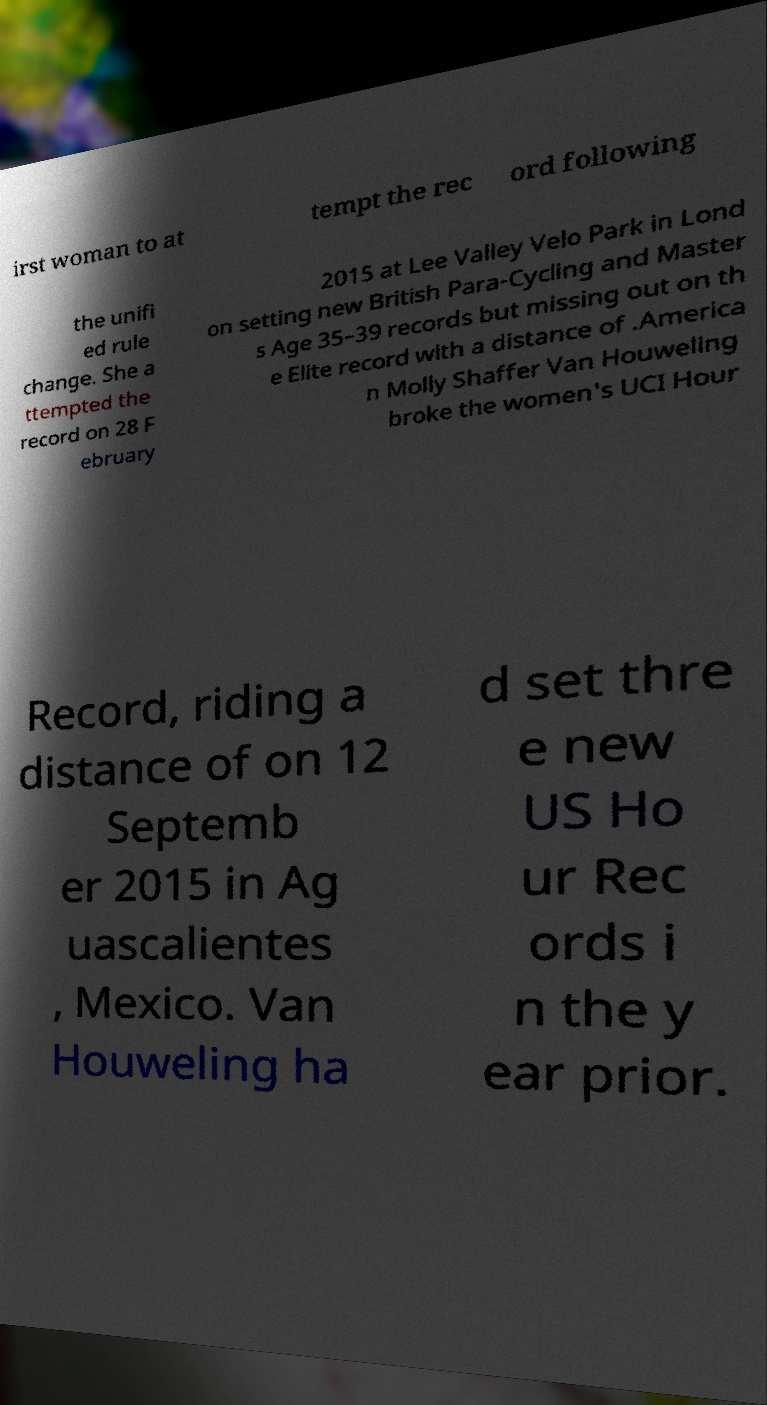I need the written content from this picture converted into text. Can you do that? irst woman to at tempt the rec ord following the unifi ed rule change. She a ttempted the record on 28 F ebruary 2015 at Lee Valley Velo Park in Lond on setting new British Para-Cycling and Master s Age 35–39 records but missing out on th e Elite record with a distance of .America n Molly Shaffer Van Houweling broke the women's UCI Hour Record, riding a distance of on 12 Septemb er 2015 in Ag uascalientes , Mexico. Van Houweling ha d set thre e new US Ho ur Rec ords i n the y ear prior. 